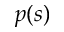<formula> <loc_0><loc_0><loc_500><loc_500>p ( s )</formula> 